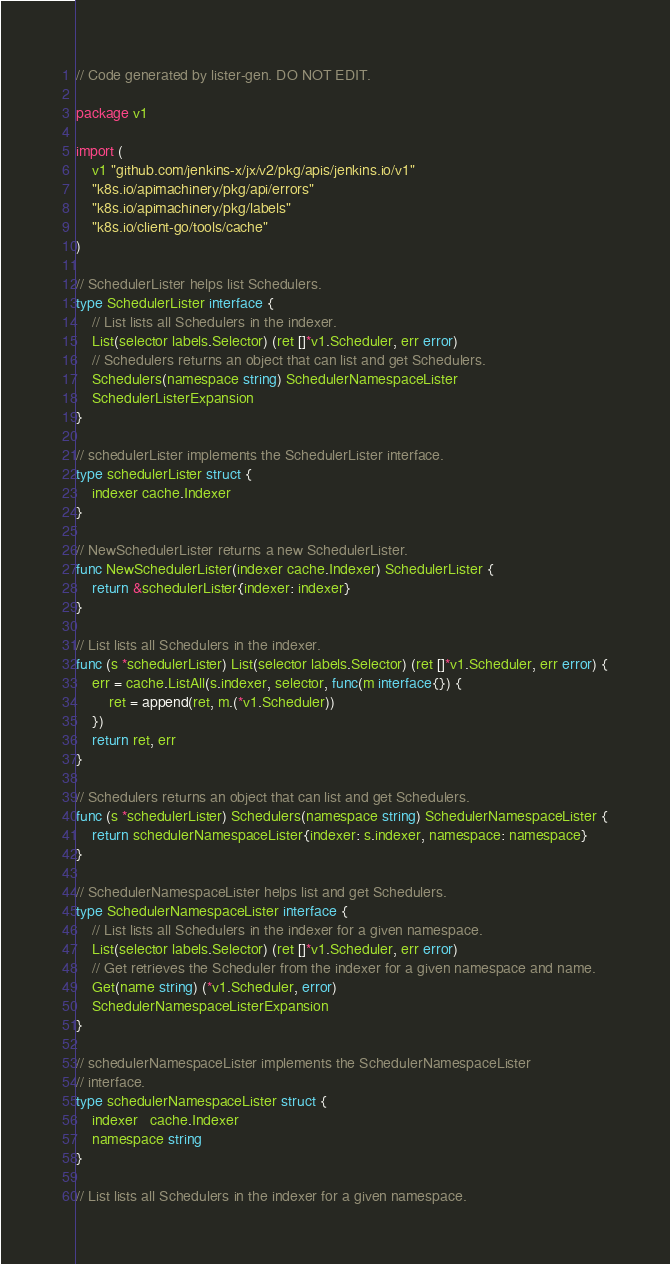Convert code to text. <code><loc_0><loc_0><loc_500><loc_500><_Go_>// Code generated by lister-gen. DO NOT EDIT.

package v1

import (
	v1 "github.com/jenkins-x/jx/v2/pkg/apis/jenkins.io/v1"
	"k8s.io/apimachinery/pkg/api/errors"
	"k8s.io/apimachinery/pkg/labels"
	"k8s.io/client-go/tools/cache"
)

// SchedulerLister helps list Schedulers.
type SchedulerLister interface {
	// List lists all Schedulers in the indexer.
	List(selector labels.Selector) (ret []*v1.Scheduler, err error)
	// Schedulers returns an object that can list and get Schedulers.
	Schedulers(namespace string) SchedulerNamespaceLister
	SchedulerListerExpansion
}

// schedulerLister implements the SchedulerLister interface.
type schedulerLister struct {
	indexer cache.Indexer
}

// NewSchedulerLister returns a new SchedulerLister.
func NewSchedulerLister(indexer cache.Indexer) SchedulerLister {
	return &schedulerLister{indexer: indexer}
}

// List lists all Schedulers in the indexer.
func (s *schedulerLister) List(selector labels.Selector) (ret []*v1.Scheduler, err error) {
	err = cache.ListAll(s.indexer, selector, func(m interface{}) {
		ret = append(ret, m.(*v1.Scheduler))
	})
	return ret, err
}

// Schedulers returns an object that can list and get Schedulers.
func (s *schedulerLister) Schedulers(namespace string) SchedulerNamespaceLister {
	return schedulerNamespaceLister{indexer: s.indexer, namespace: namespace}
}

// SchedulerNamespaceLister helps list and get Schedulers.
type SchedulerNamespaceLister interface {
	// List lists all Schedulers in the indexer for a given namespace.
	List(selector labels.Selector) (ret []*v1.Scheduler, err error)
	// Get retrieves the Scheduler from the indexer for a given namespace and name.
	Get(name string) (*v1.Scheduler, error)
	SchedulerNamespaceListerExpansion
}

// schedulerNamespaceLister implements the SchedulerNamespaceLister
// interface.
type schedulerNamespaceLister struct {
	indexer   cache.Indexer
	namespace string
}

// List lists all Schedulers in the indexer for a given namespace.</code> 